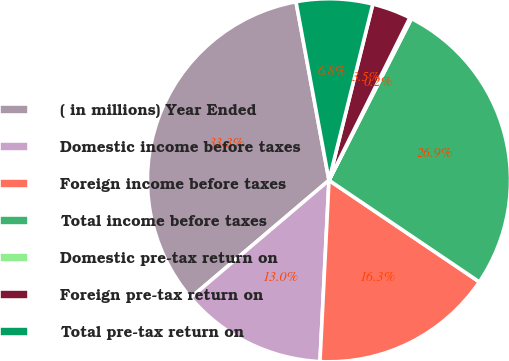Convert chart. <chart><loc_0><loc_0><loc_500><loc_500><pie_chart><fcel>( in millions) Year Ended<fcel>Domestic income before taxes<fcel>Foreign income before taxes<fcel>Total income before taxes<fcel>Domestic pre-tax return on<fcel>Foreign pre-tax return on<fcel>Total pre-tax return on<nl><fcel>33.29%<fcel>13.01%<fcel>16.33%<fcel>26.95%<fcel>0.16%<fcel>3.47%<fcel>6.79%<nl></chart> 